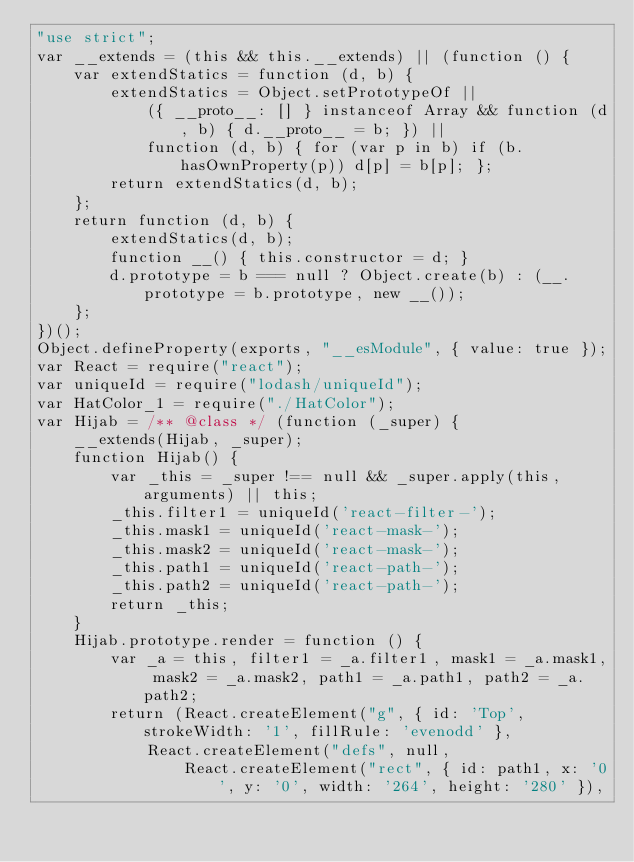Convert code to text. <code><loc_0><loc_0><loc_500><loc_500><_JavaScript_>"use strict";
var __extends = (this && this.__extends) || (function () {
    var extendStatics = function (d, b) {
        extendStatics = Object.setPrototypeOf ||
            ({ __proto__: [] } instanceof Array && function (d, b) { d.__proto__ = b; }) ||
            function (d, b) { for (var p in b) if (b.hasOwnProperty(p)) d[p] = b[p]; };
        return extendStatics(d, b);
    };
    return function (d, b) {
        extendStatics(d, b);
        function __() { this.constructor = d; }
        d.prototype = b === null ? Object.create(b) : (__.prototype = b.prototype, new __());
    };
})();
Object.defineProperty(exports, "__esModule", { value: true });
var React = require("react");
var uniqueId = require("lodash/uniqueId");
var HatColor_1 = require("./HatColor");
var Hijab = /** @class */ (function (_super) {
    __extends(Hijab, _super);
    function Hijab() {
        var _this = _super !== null && _super.apply(this, arguments) || this;
        _this.filter1 = uniqueId('react-filter-');
        _this.mask1 = uniqueId('react-mask-');
        _this.mask2 = uniqueId('react-mask-');
        _this.path1 = uniqueId('react-path-');
        _this.path2 = uniqueId('react-path-');
        return _this;
    }
    Hijab.prototype.render = function () {
        var _a = this, filter1 = _a.filter1, mask1 = _a.mask1, mask2 = _a.mask2, path1 = _a.path1, path2 = _a.path2;
        return (React.createElement("g", { id: 'Top', strokeWidth: '1', fillRule: 'evenodd' },
            React.createElement("defs", null,
                React.createElement("rect", { id: path1, x: '0', y: '0', width: '264', height: '280' }),</code> 